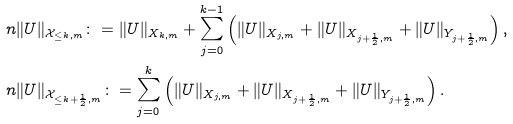Convert formula to latex. <formula><loc_0><loc_0><loc_500><loc_500>\ n & \| U \| _ { \mathcal { X } _ { \leq k , m } } \colon = \| U \| _ { X _ { k , m } } + \sum _ { j = 0 } ^ { k - 1 } \left ( \| U \| _ { X _ { j , m } } + \| U \| _ { X _ { j + \frac { 1 } { 2 } , m } } + \| U \| _ { Y _ { j + \frac { 1 } { 2 } , m } } \right ) , \\ \ n & \| U \| _ { \mathcal { X } _ { \leq k + \frac { 1 } { 2 } , m } } \colon = \sum _ { j = 0 } ^ { k } \left ( \| U \| _ { X _ { j , m } } + \| U \| _ { X _ { j + \frac { 1 } { 2 } , m } } + \| U \| _ { Y _ { j + \frac { 1 } { 2 } , m } } \right ) .</formula> 